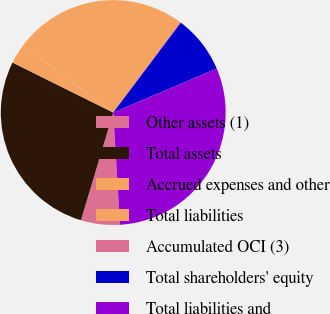Convert chart. <chart><loc_0><loc_0><loc_500><loc_500><pie_chart><fcel>Other assets (1)<fcel>Total assets<fcel>Accrued expenses and other<fcel>Total liabilities<fcel>Accumulated OCI (3)<fcel>Total shareholders' equity<fcel>Total liabilities and<nl><fcel>5.6%<fcel>27.69%<fcel>2.86%<fcel>24.95%<fcel>0.12%<fcel>8.34%<fcel>30.43%<nl></chart> 